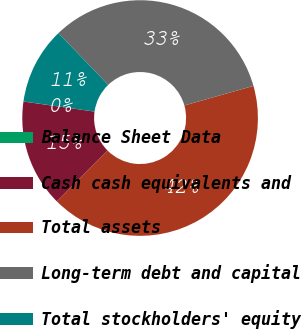Convert chart. <chart><loc_0><loc_0><loc_500><loc_500><pie_chart><fcel>Balance Sheet Data<fcel>Cash cash equivalents and<fcel>Total assets<fcel>Long-term debt and capital<fcel>Total stockholders' equity<nl><fcel>0.01%<fcel>14.75%<fcel>41.88%<fcel>32.8%<fcel>10.56%<nl></chart> 